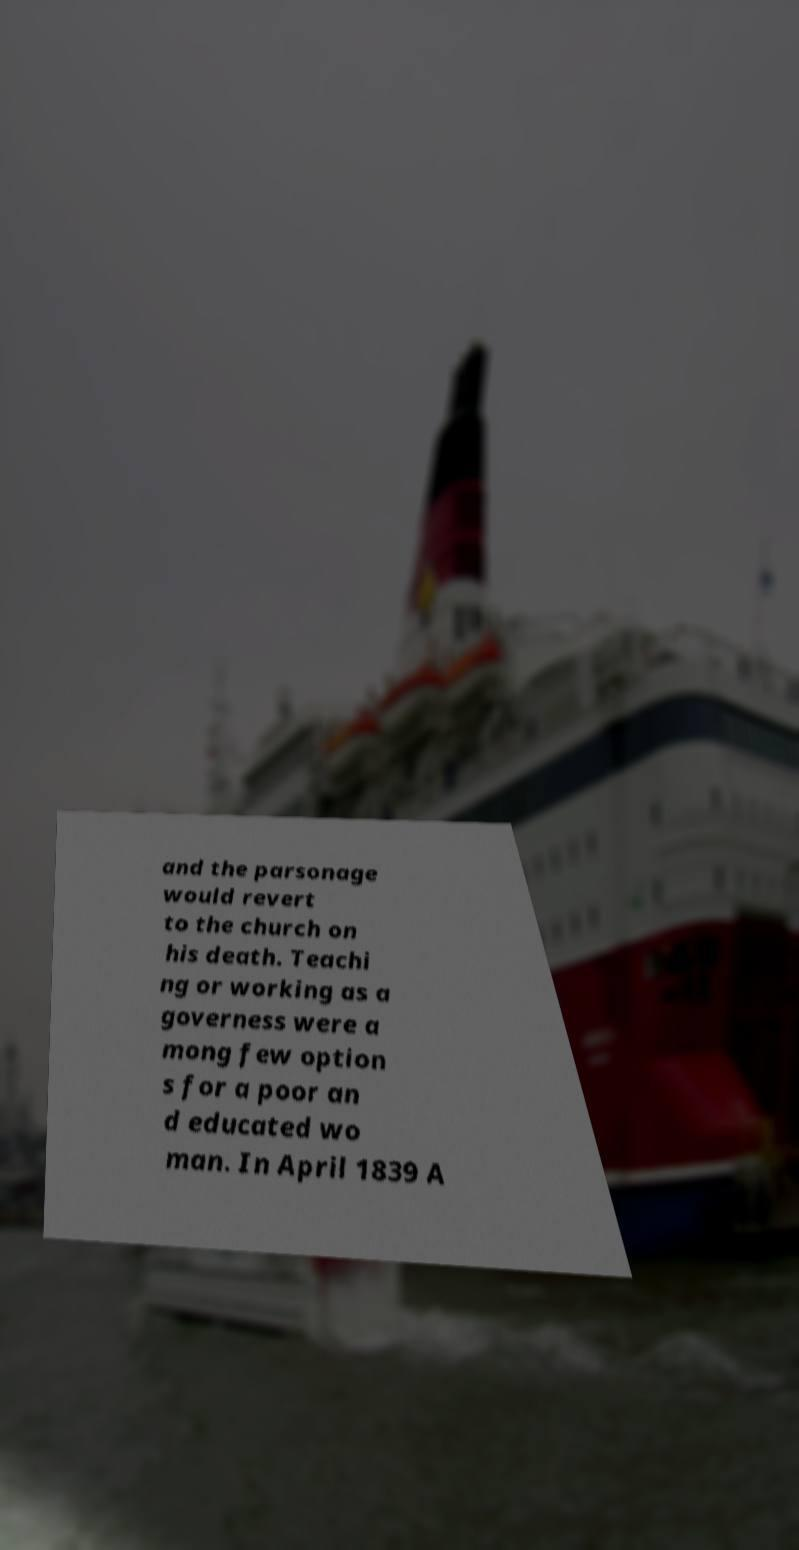Could you assist in decoding the text presented in this image and type it out clearly? and the parsonage would revert to the church on his death. Teachi ng or working as a governess were a mong few option s for a poor an d educated wo man. In April 1839 A 